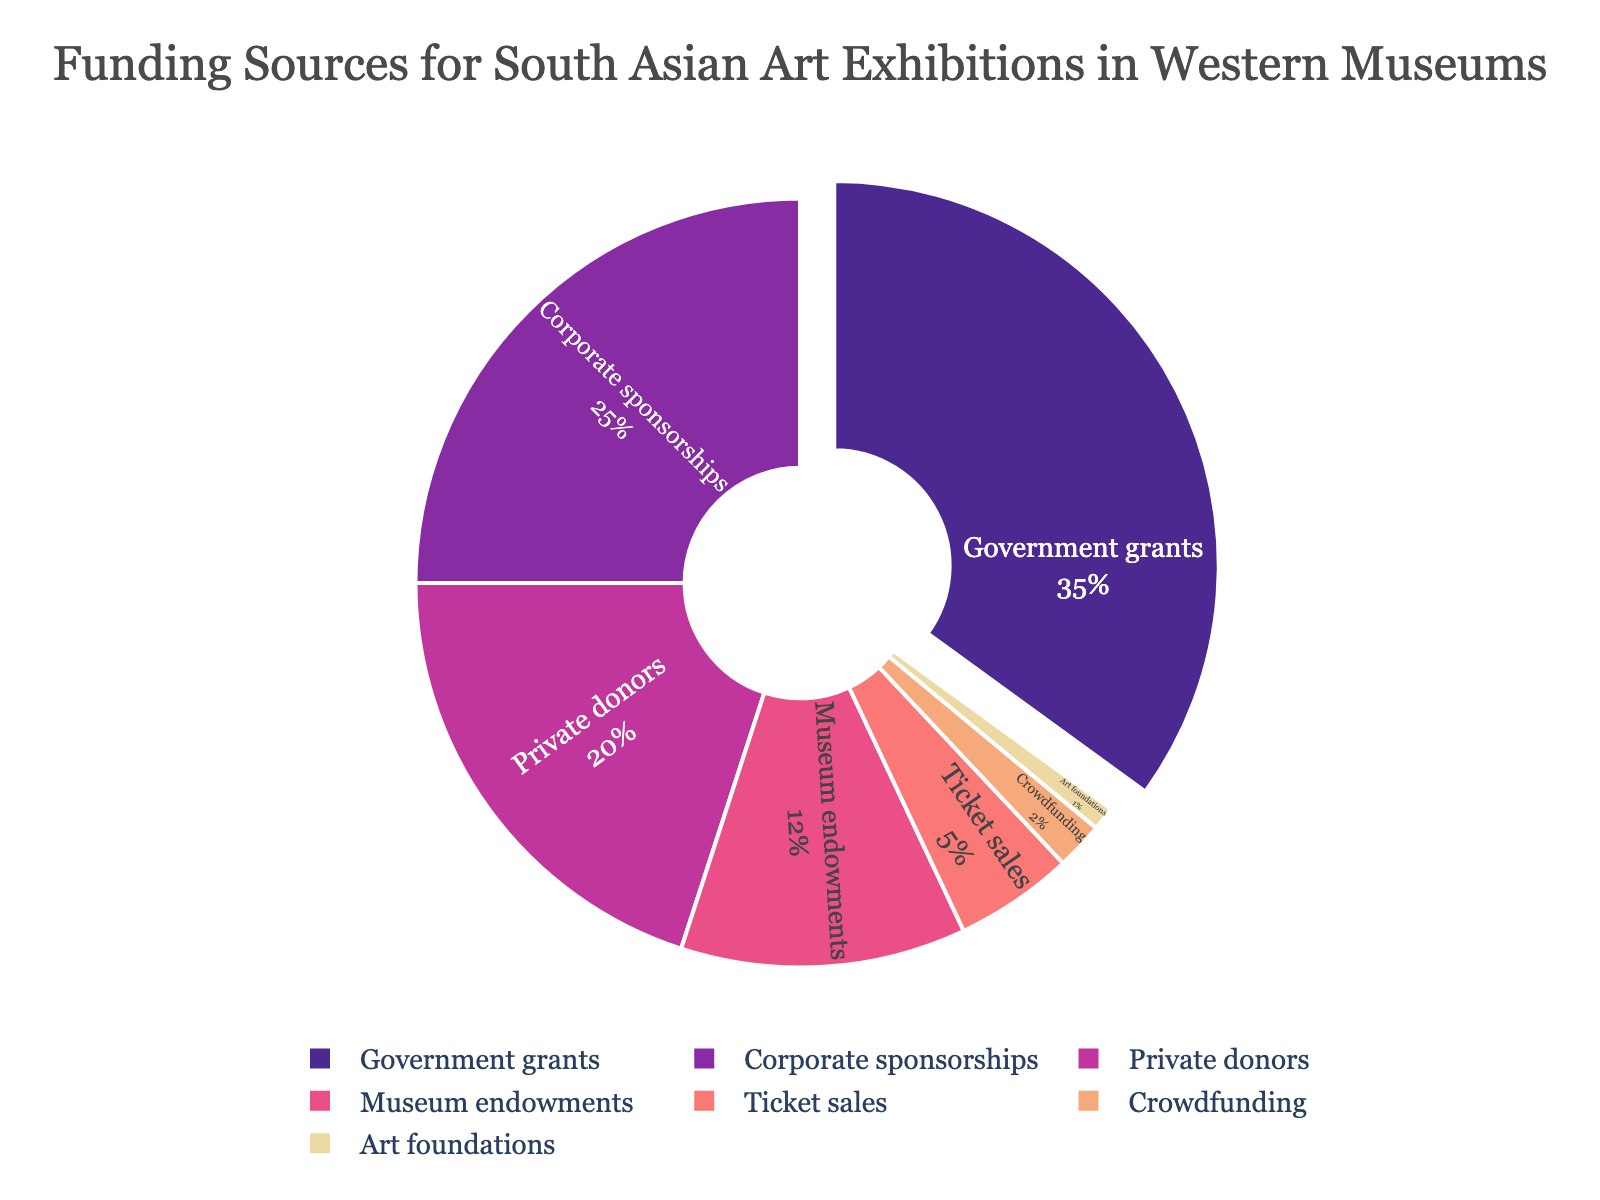What is the largest funding source for South Asian art exhibitions in Western museums? Look at the pie chart and identify the category with the largest segment. The "Government grants" segment is the largest, accounting for the highest percentage of the whole.
Answer: Government grants Which two categories combined contribute to more than half of the funding? Locate the two largest segments in the pie chart. Adding the percentages of "Government grants" (35%) and "Corporate sponsorships" (25%) gives a total of 60%, which is more than half.
Answer: Government grants and Corporate sponsorships Between Corporate sponsorships and Private donors, which provides less funding? Compare the sizes of the segments labeled "Corporate sponsorships" (25%) and "Private donors" (20%). The "Private donors" segment is smaller.
Answer: Private donors How much more percentage do Government grants provide compared to Museum endowments? Subtract the percentage of "Museum endowments" (12%) from "Government grants" (35%) to find the difference. The calculation is 35% - 12% = 23%.
Answer: 23% What is the total percentage of funding from Private donors, Museum endowments, and Ticket sales? Sum the individual percentages for "Private donors" (20%), "Museum endowments" (12%), and "Ticket sales" (5%) to find the total. The calculation is 20% + 12% + 5% = 37%.
Answer: 37% Which funding source has the smallest contribution, and what is its percentage? Identify the smallest segment in the pie chart. The "Art foundations" segment is the smallest, accounting for 1% of the total funding.
Answer: Art foundations, 1% How does the percentage contribution of Crowdfunding compare to that of Ticket sales? Compare the Crowdfunding and Ticket sales segments. Crowdfunding contributes 2%, whereas Ticket sales contribute 5%. Thus, Crowdfunding contributes less than Ticket sales.
Answer: Crowdfunding contributes less What is the difference between the funding percentages of Corporate sponsorships and Private donors? Subtract the percentage of "Private donors" (20%) from "Corporate sponsorships" (25%). The calculation is 25% - 20% = 5%.
Answer: 5% What is the second largest source of funding for South Asian art exhibitions in Western museums? Identify the second largest segment in the pie chart. The "Corporate sponsorships" segment, at 25%, is the second-largest source of funding.
Answer: Corporate sponsorships What percentage of funding comes from sources other than Corporate sponsorships and Government grants? Subtract the combined percentage of "Corporate sponsorships" (25%) and "Government grants" (35%) from 100%. The calculation is 100% - (25% + 35%) = 40%.
Answer: 40% 